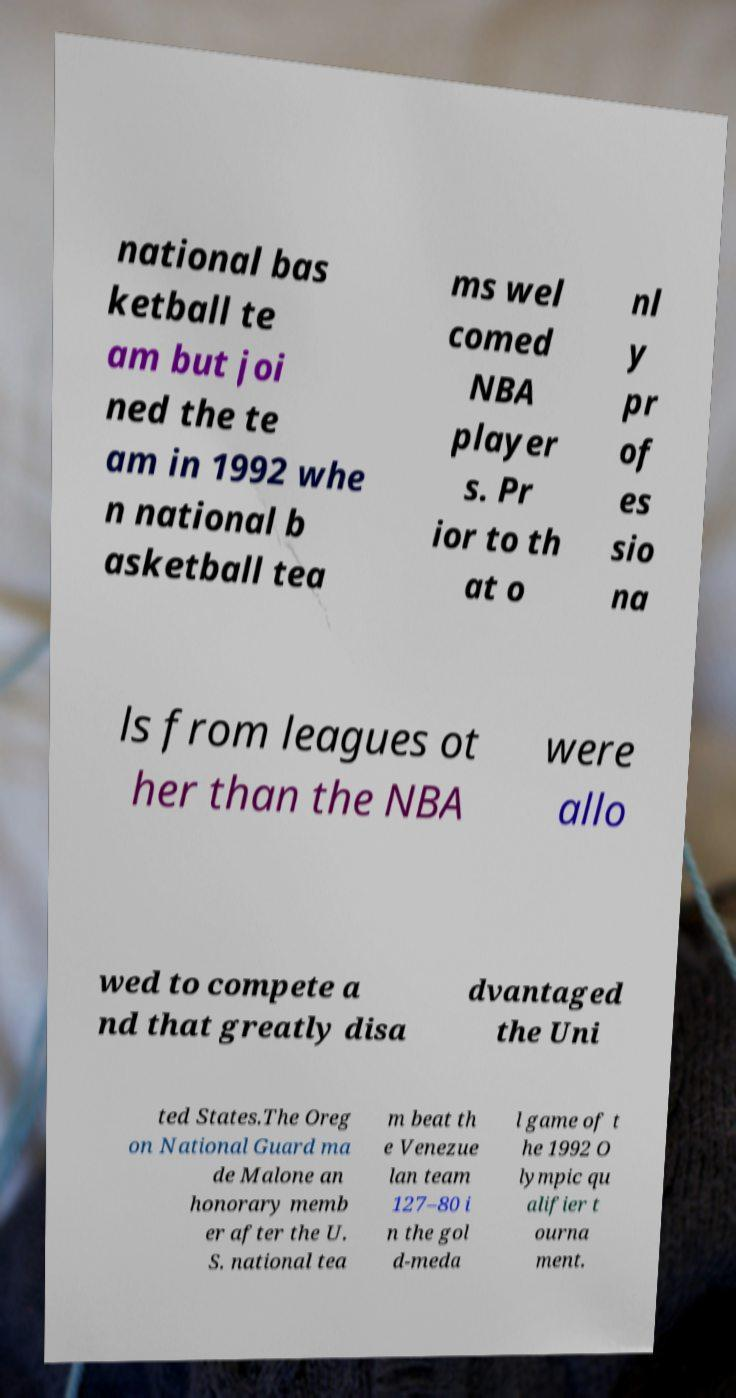Please identify and transcribe the text found in this image. national bas ketball te am but joi ned the te am in 1992 whe n national b asketball tea ms wel comed NBA player s. Pr ior to th at o nl y pr of es sio na ls from leagues ot her than the NBA were allo wed to compete a nd that greatly disa dvantaged the Uni ted States.The Oreg on National Guard ma de Malone an honorary memb er after the U. S. national tea m beat th e Venezue lan team 127–80 i n the gol d-meda l game of t he 1992 O lympic qu alifier t ourna ment. 